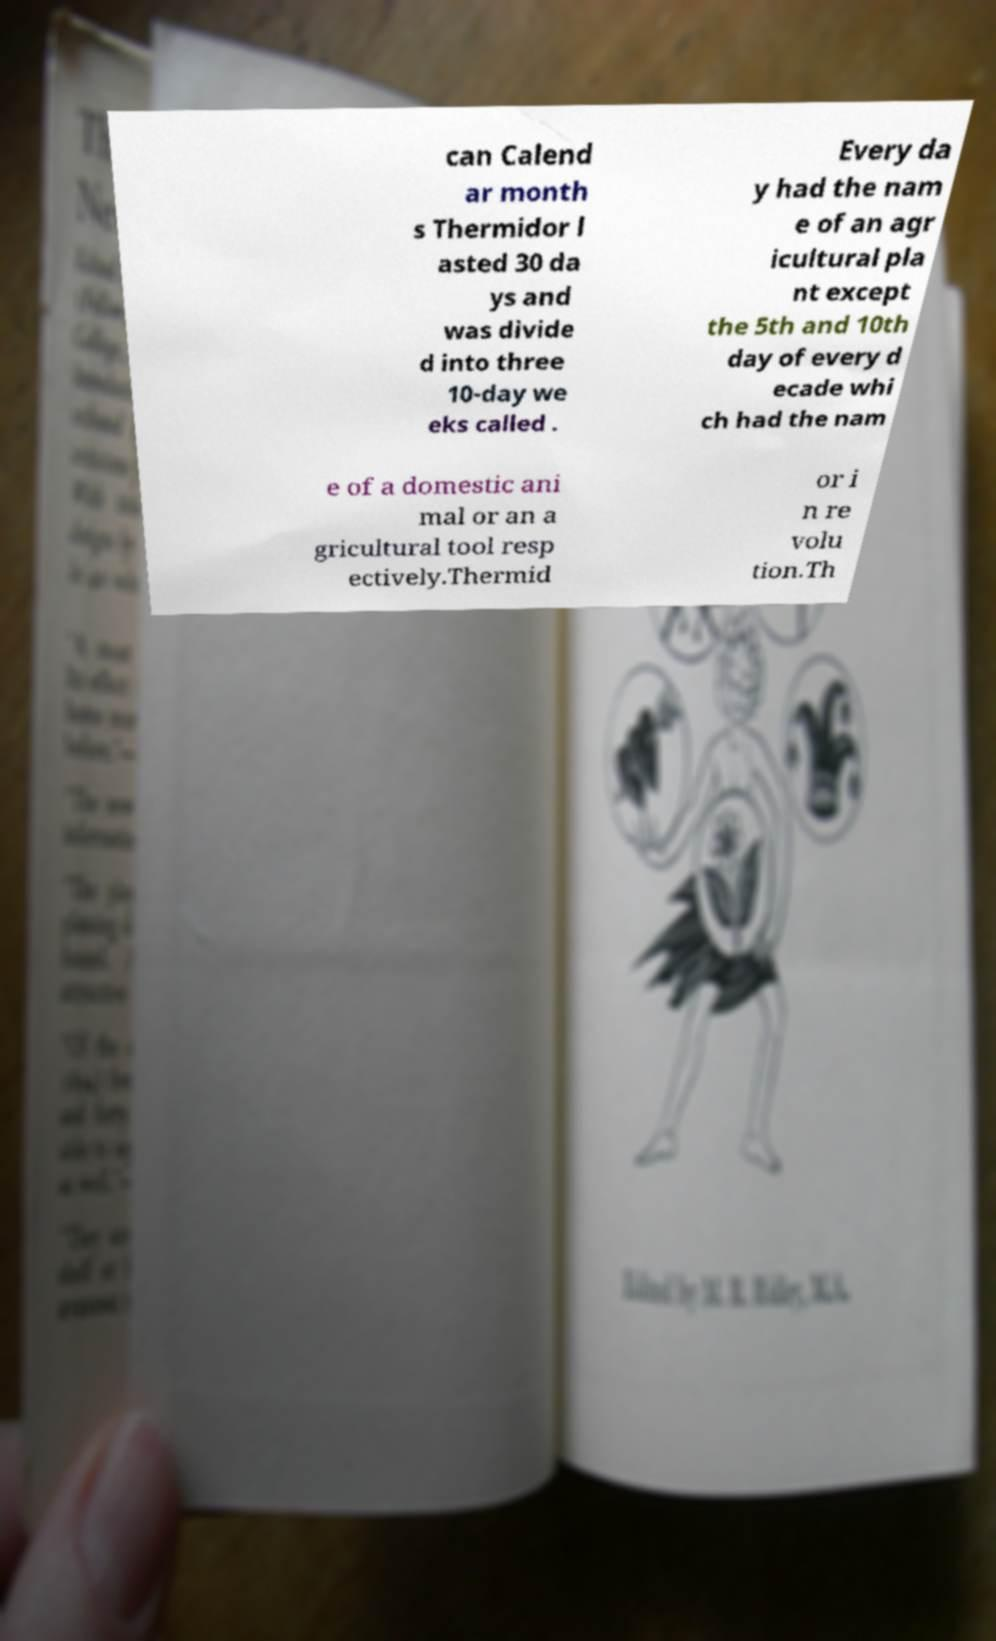Can you accurately transcribe the text from the provided image for me? can Calend ar month s Thermidor l asted 30 da ys and was divide d into three 10-day we eks called . Every da y had the nam e of an agr icultural pla nt except the 5th and 10th day of every d ecade whi ch had the nam e of a domestic ani mal or an a gricultural tool resp ectively.Thermid or i n re volu tion.Th 